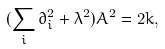<formula> <loc_0><loc_0><loc_500><loc_500>( \sum _ { i } \partial _ { i } ^ { 2 } + \lambda ^ { 2 } ) A ^ { 2 } = 2 k ,</formula> 